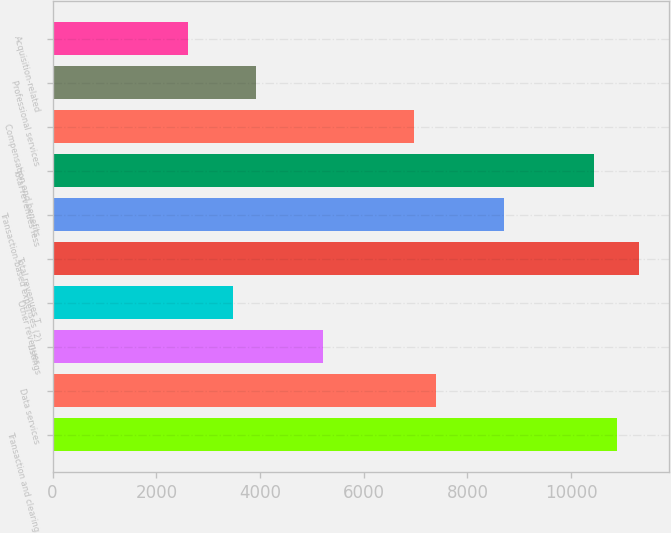<chart> <loc_0><loc_0><loc_500><loc_500><bar_chart><fcel>Transaction and clearing<fcel>Data services<fcel>Listings<fcel>Other revenues<fcel>Total revenues T<fcel>Transaction-based expenses (2)<fcel>Total revenues less<fcel>Compensation and benefits<fcel>Professional services<fcel>Acquisition-related<nl><fcel>10879.3<fcel>7398.07<fcel>5222.32<fcel>3481.72<fcel>11314.4<fcel>8703.52<fcel>10444.1<fcel>6962.92<fcel>3916.87<fcel>2611.42<nl></chart> 